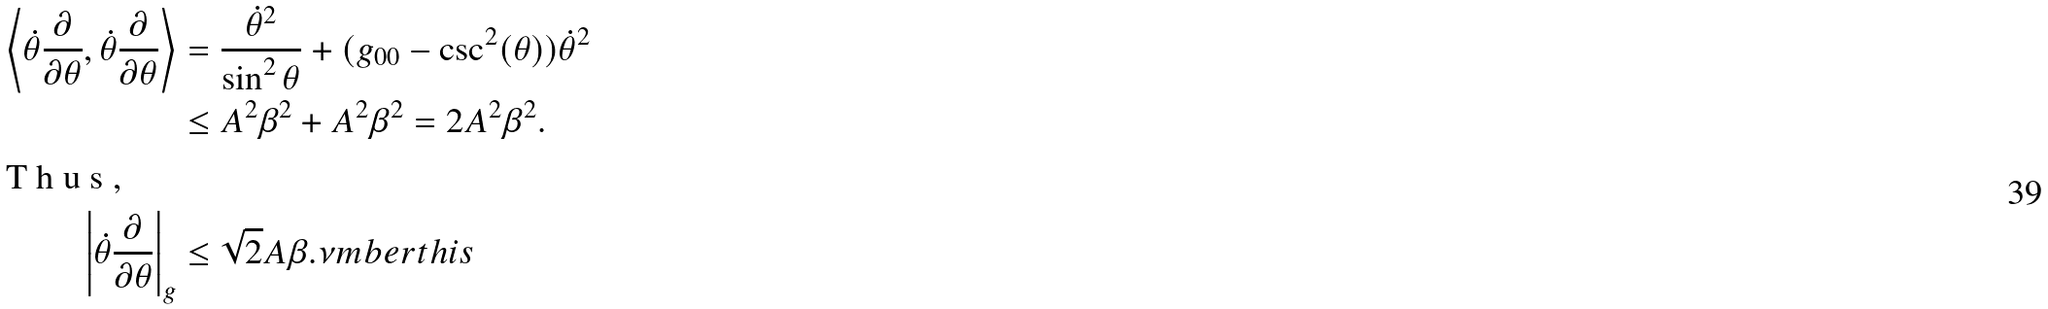<formula> <loc_0><loc_0><loc_500><loc_500>\left \langle \dot { \theta } \frac { \partial } { \partial \theta } , \dot { \theta } \frac { \partial } { \partial \theta } \right \rangle & = \frac { \dot { \theta } ^ { 2 } } { \sin ^ { 2 } \theta } + ( g _ { 0 0 } - \csc ^ { 2 } ( \theta ) ) \dot { \theta } ^ { 2 } \\ & \leq A ^ { 2 } \beta ^ { 2 } + A ^ { 2 } \beta ^ { 2 } = 2 A ^ { 2 } \beta ^ { 2 } . \intertext { T h u s , } \left | \dot { \theta } \frac { \partial } { \partial \theta } \right | _ { g } & \leq \sqrt { 2 } A \beta . \nu m b e r t h i s</formula> 